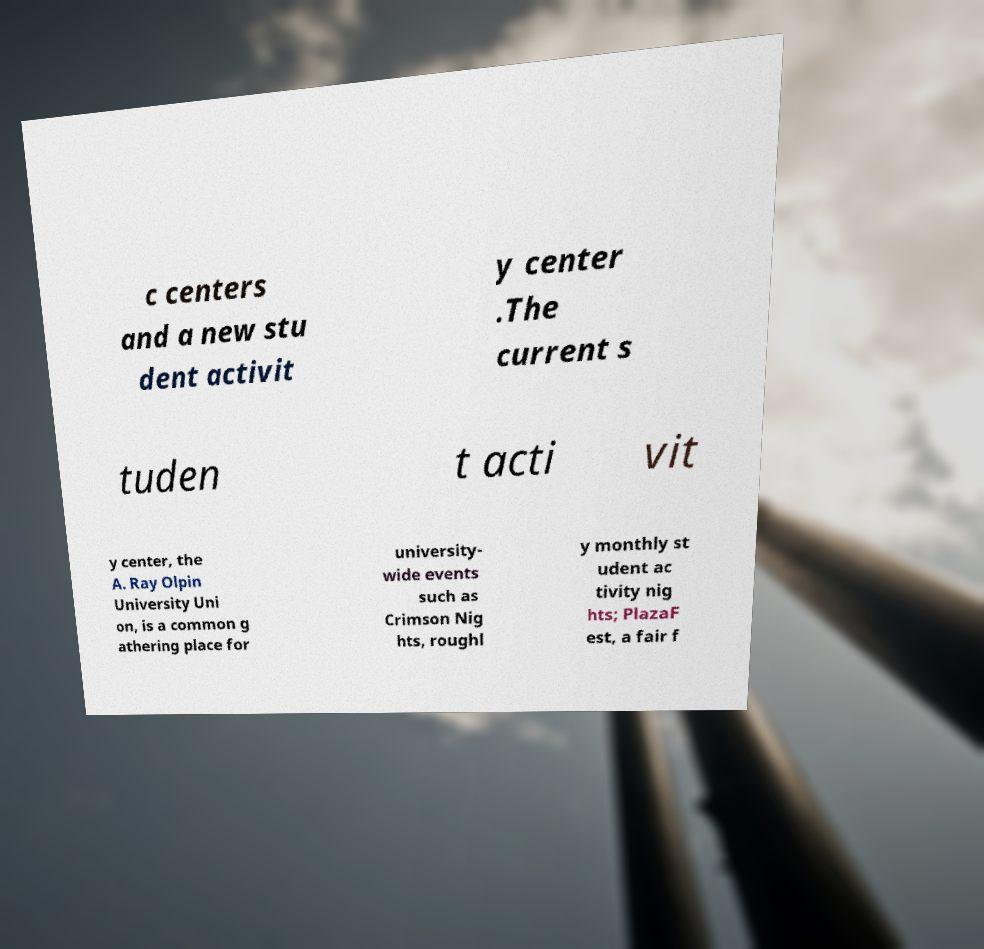I need the written content from this picture converted into text. Can you do that? c centers and a new stu dent activit y center .The current s tuden t acti vit y center, the A. Ray Olpin University Uni on, is a common g athering place for university- wide events such as Crimson Nig hts, roughl y monthly st udent ac tivity nig hts; PlazaF est, a fair f 